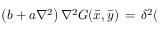<formula> <loc_0><loc_0><loc_500><loc_500>\left ( b + a \nabla ^ { 2 } \right ) \nabla ^ { 2 } G ( \bar { x } , \bar { y } ) \, = \, \delta ^ { 2 } (</formula> 